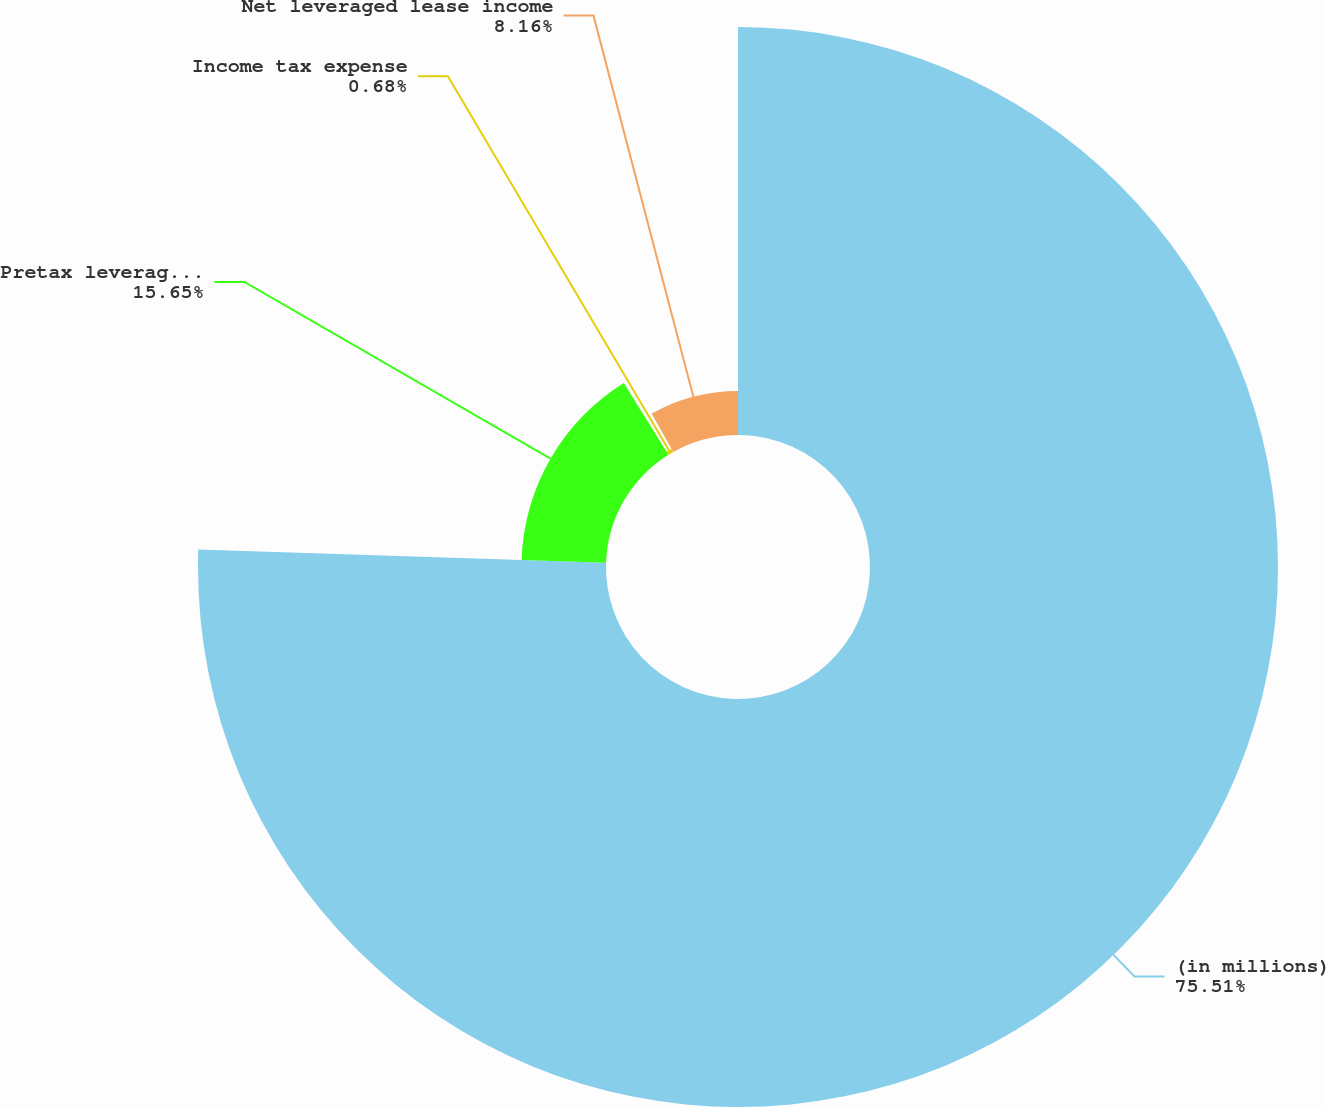Convert chart to OTSL. <chart><loc_0><loc_0><loc_500><loc_500><pie_chart><fcel>(in millions)<fcel>Pretax leveraged lease income<fcel>Income tax expense<fcel>Net leveraged lease income<nl><fcel>75.52%<fcel>15.65%<fcel>0.68%<fcel>8.16%<nl></chart> 